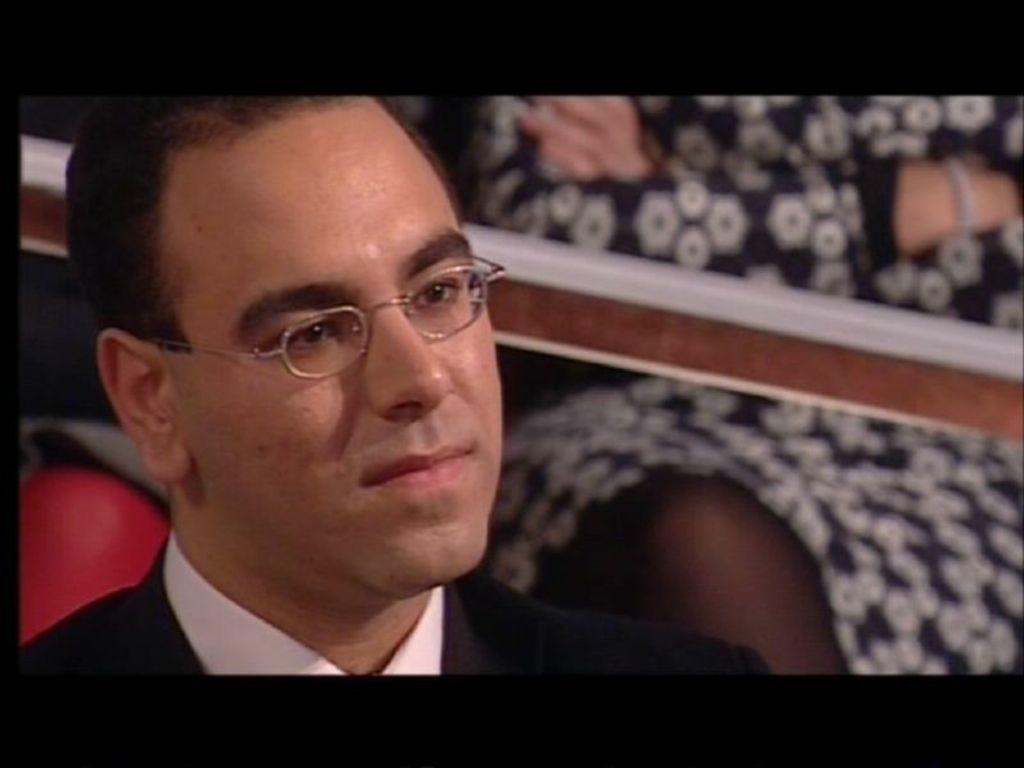Who is present in the image? There is a man in the image. Can you describe the background of the image? There is a person in the background of the image. What is in front of the person in the background? There is a rod in front of the person in the background. What type of teeth does the servant have in the image? There is no servant present in the image, and therefore no teeth can be observed. 